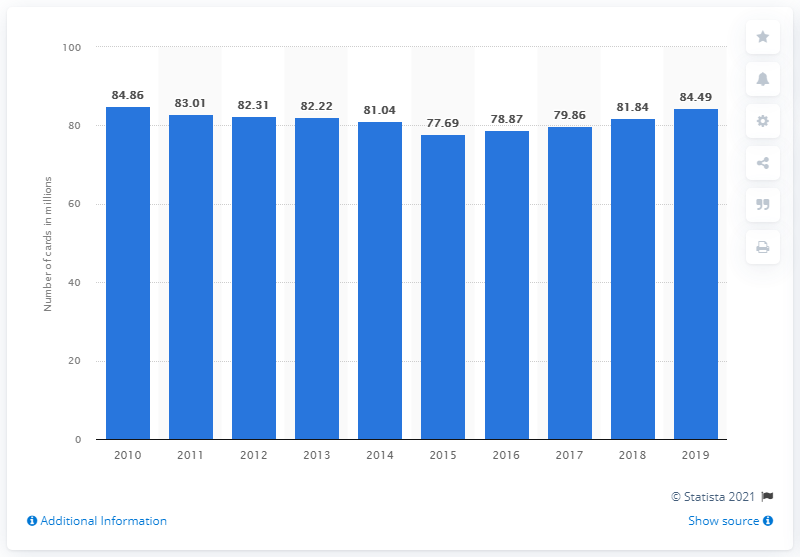Specify some key components in this picture. In France, the number of payment cards issued between 2010 and 2019 was 84.49 million. 